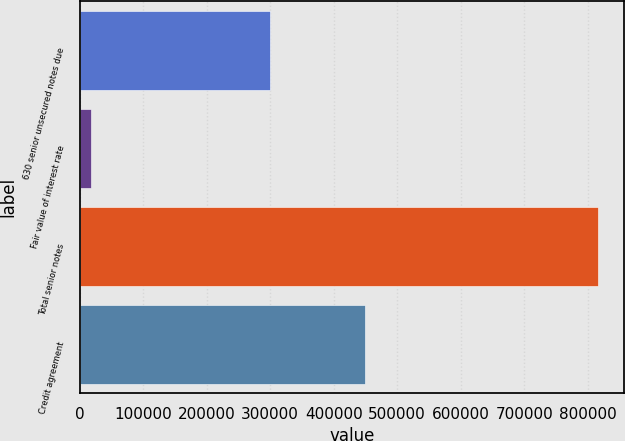Convert chart to OTSL. <chart><loc_0><loc_0><loc_500><loc_500><bar_chart><fcel>630 senior unsecured notes due<fcel>Fair value of interest rate<fcel>Total senior notes<fcel>Credit agreement<nl><fcel>299335<fcel>18093<fcel>816035<fcel>450000<nl></chart> 